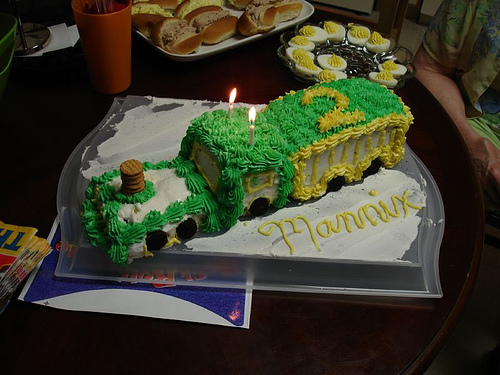<image>What popular summertime desert features this yellow item? It's ambiguous to answer. The yellow item could feature in a cake, a muffin, deviled eggs, or a pie. What continent do you think this is? I am not sure which continent this is. It could be North America, Asia, or Europe. What marvel comic character is in this picture? There is no Marvel comic character in the image. What popular summertime desert features this yellow item? I am not sure what popular summertime dessert features this yellow item. It can be cake, deviled eggs, muffin, or pie. What continent do you think this is? I am not sure what continent this is. It could be North America, Europe, or Asia. What marvel comic character is in this picture? I don't know what marvel comic character is in this picture. It doesn't seem to have any marvel character. 